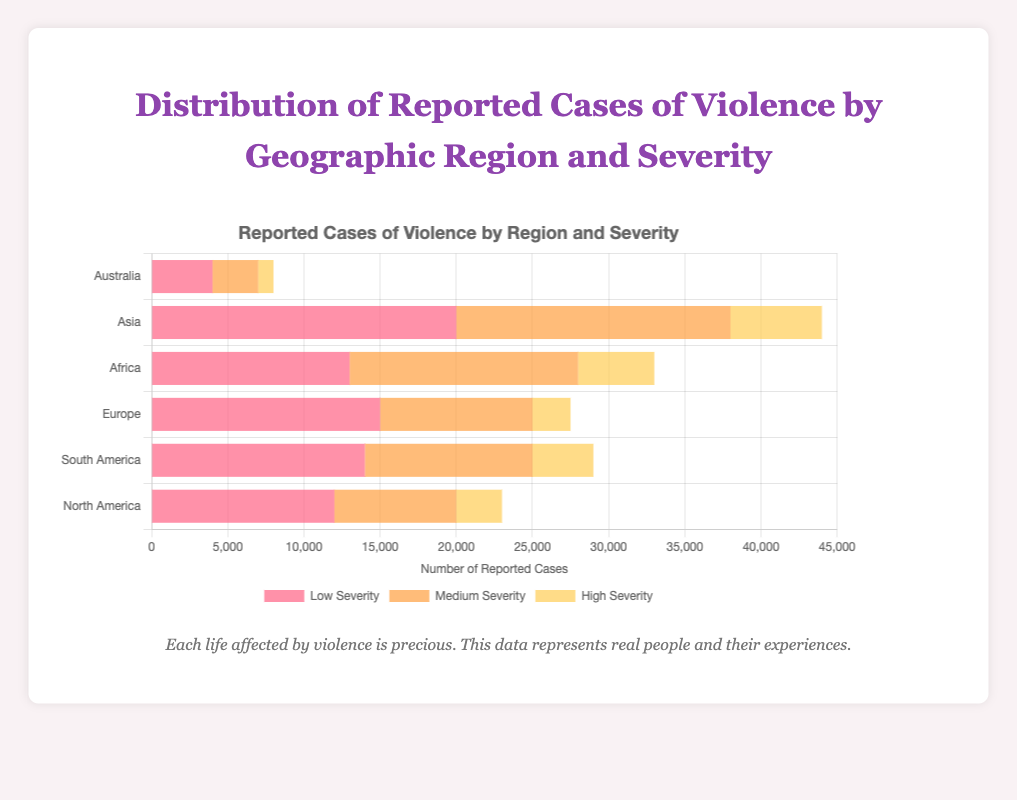Which region has the highest number of high severity cases of violence? Look at the length of the bars representing high severity cases across all regions and find the longest one. Asia has the longest bar for high severity cases with 6000 reported cases.
Answer: Asia What is the total number of reported cases of violence in North America? Sum the reported cases across all severity levels in North America: 12000 (low) + 8000 (medium) + 3000 (high) = 23000 total cases.
Answer: 23000 How many more medium severity cases are reported in Africa compared to Europe? Subtract the number of medium severity cases in Europe from those in Africa: 15000 (Africa) - 10000 (Europe) = 5000 more cases.
Answer: 5000 Which regions have more low severity cases than medium severity cases? Compare the lengths of the low severity and medium severity bars for each region. North America (12000 > 8000), Europe (15000 > 10000), and Australia (4000 > 3000) have more low severity cases than medium severity cases.
Answer: North America, Europe, Australia What is the average number of high severity cases reported across all regions? Sum the number of high severity cases across all regions and divide by the number of regions: (3000 + 4000 + 2500 + 5000 + 6000 + 1000) / 6 = 21500 / 6 ≈ 3583.33.
Answer: 3583.33 Which severity level is most reported in South America? Compare the lengths of the bars for each severity level in South America. Low severity has the highest number of reported cases with 14000.
Answer: Low severity Which region has the least total reported cases? Calculate the total cases for each region and find the lowest one: 
North America: 12000 + 8000 + 3000 = 23000
South America: 14000 + 11000 + 4000 = 29000
Europe: 15000 + 10000 + 2500 = 27500
Africa: 13000 + 15000 + 5000 = 33000
Asia: 20000 + 18000 + 6000 = 44000
Australia: 4000 + 3000 + 1000 = 8000
Australia has the least total reported cases with 8000.
Answer: Australia What percentage of total reported cases in Asia are of high severity? First, find the total number of reported cases in Asia: 20000 (low) + 18000 (medium) + 6000 (high) = 44000. Then, calculate the percentage of high severity cases: (6000 / 44000) * 100 ≈ 13.64%.
Answer: 13.64% Compare the number of medium severity cases in Asia to the number of medium severity cases in North America. Which is higher and by how much? Find the difference between the medium severity cases in Asia and North America: 18000 (Asia) - 8000 (North America) = 10000. Asia has 10000 more medium severity cases than North America.
Answer: Asia by 10000 